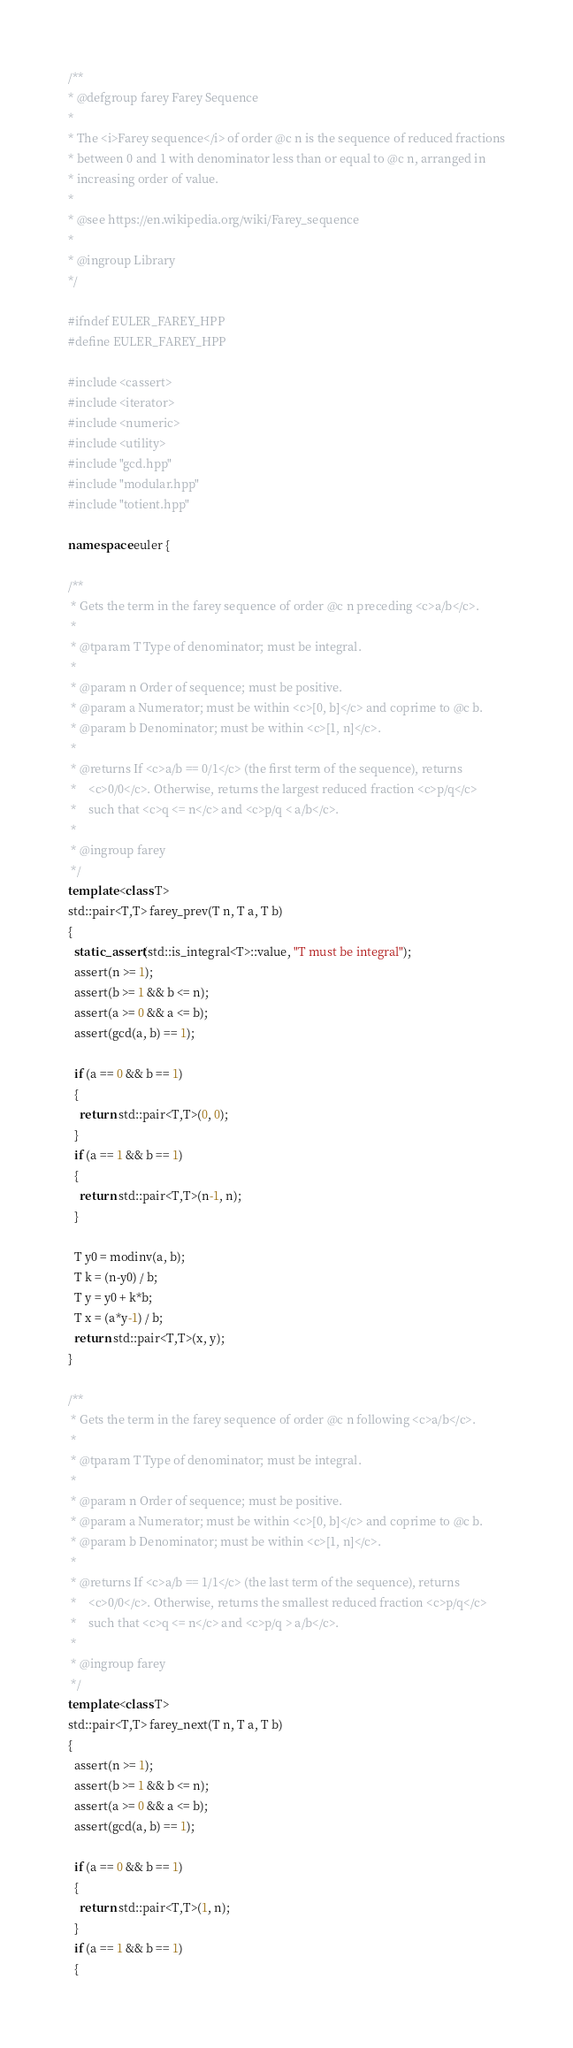<code> <loc_0><loc_0><loc_500><loc_500><_C++_>/**
* @defgroup farey Farey Sequence
*
* The <i>Farey sequence</i> of order @c n is the sequence of reduced fractions
* between 0 and 1 with denominator less than or equal to @c n, arranged in
* increasing order of value.
*
* @see https://en.wikipedia.org/wiki/Farey_sequence
*
* @ingroup Library
*/

#ifndef EULER_FAREY_HPP
#define EULER_FAREY_HPP

#include <cassert>
#include <iterator>
#include <numeric>
#include <utility>
#include "gcd.hpp"
#include "modular.hpp"
#include "totient.hpp"

namespace euler {

/**
 * Gets the term in the farey sequence of order @c n preceding <c>a/b</c>.
 *
 * @tparam T Type of denominator; must be integral.
 *
 * @param n Order of sequence; must be positive.
 * @param a Numerator; must be within <c>[0, b]</c> and coprime to @c b.
 * @param b Denominator; must be within <c>[1, n]</c>.
 *
 * @returns If <c>a/b == 0/1</c> (the first term of the sequence), returns
 *    <c>0/0</c>. Otherwise, returns the largest reduced fraction <c>p/q</c>
 *    such that <c>q <= n</c> and <c>p/q < a/b</c>.
 *
 * @ingroup farey
 */
template <class T>
std::pair<T,T> farey_prev(T n, T a, T b)
{
  static_assert(std::is_integral<T>::value, "T must be integral");
  assert(n >= 1);
  assert(b >= 1 && b <= n);
  assert(a >= 0 && a <= b);
  assert(gcd(a, b) == 1);

  if (a == 0 && b == 1)
  {
    return std::pair<T,T>(0, 0);
  }
  if (a == 1 && b == 1)
  {
    return std::pair<T,T>(n-1, n);
  }

  T y0 = modinv(a, b);
  T k = (n-y0) / b;
  T y = y0 + k*b;
  T x = (a*y-1) / b;
  return std::pair<T,T>(x, y);
}

/**
 * Gets the term in the farey sequence of order @c n following <c>a/b</c>.
 *
 * @tparam T Type of denominator; must be integral.
 *
 * @param n Order of sequence; must be positive.
 * @param a Numerator; must be within <c>[0, b]</c> and coprime to @c b.
 * @param b Denominator; must be within <c>[1, n]</c>.
 *
 * @returns If <c>a/b == 1/1</c> (the last term of the sequence), returns
 *    <c>0/0</c>. Otherwise, returns the smallest reduced fraction <c>p/q</c>
 *    such that <c>q <= n</c> and <c>p/q > a/b</c>.
 *
 * @ingroup farey
 */
template <class T>
std::pair<T,T> farey_next(T n, T a, T b)
{
  assert(n >= 1);
  assert(b >= 1 && b <= n);
  assert(a >= 0 && a <= b);
  assert(gcd(a, b) == 1);

  if (a == 0 && b == 1)
  {
    return std::pair<T,T>(1, n);
  }
  if (a == 1 && b == 1)
  {</code> 